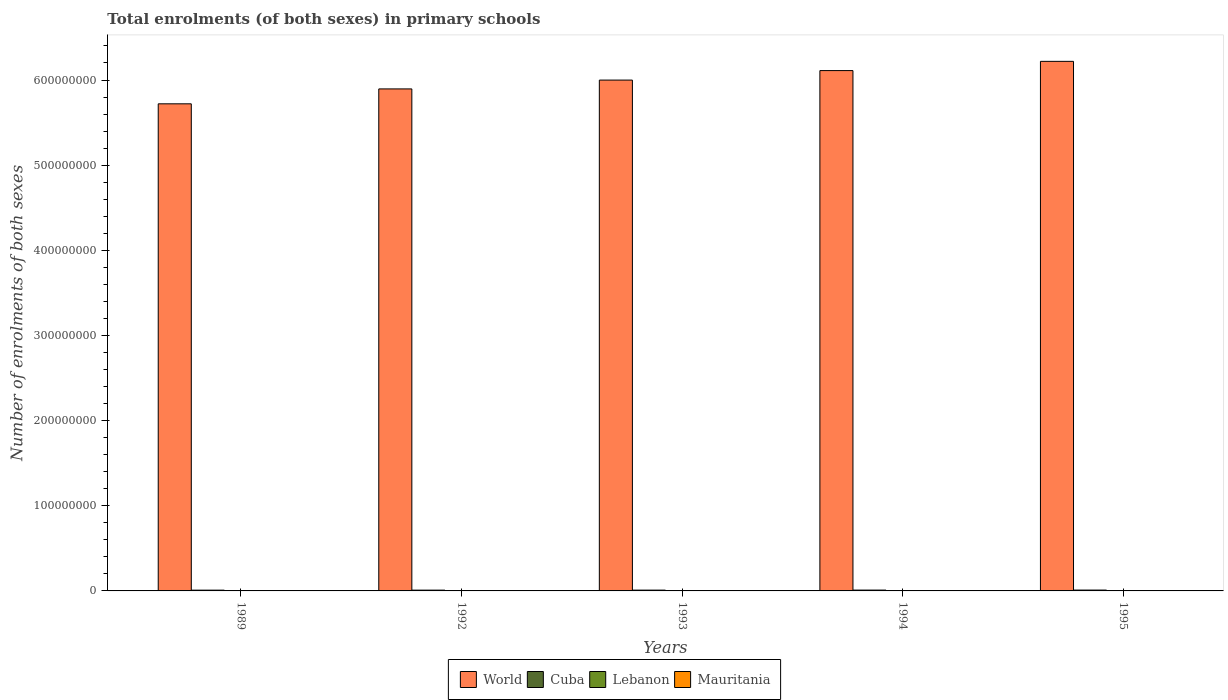Are the number of bars per tick equal to the number of legend labels?
Keep it short and to the point. Yes. How many bars are there on the 1st tick from the right?
Your answer should be very brief. 4. What is the label of the 1st group of bars from the left?
Your answer should be very brief. 1989. What is the number of enrolments in primary schools in World in 1989?
Your answer should be compact. 5.72e+08. Across all years, what is the maximum number of enrolments in primary schools in Cuba?
Make the answer very short. 1.01e+06. Across all years, what is the minimum number of enrolments in primary schools in Cuba?
Make the answer very short. 9.00e+05. In which year was the number of enrolments in primary schools in World minimum?
Make the answer very short. 1989. What is the total number of enrolments in primary schools in Lebanon in the graph?
Provide a succinct answer. 1.76e+06. What is the difference between the number of enrolments in primary schools in Lebanon in 1994 and that in 1995?
Your answer should be very brief. -4316. What is the difference between the number of enrolments in primary schools in Mauritania in 1992 and the number of enrolments in primary schools in Lebanon in 1995?
Your answer should be very brief. -1.77e+05. What is the average number of enrolments in primary schools in World per year?
Provide a short and direct response. 5.99e+08. In the year 1992, what is the difference between the number of enrolments in primary schools in Lebanon and number of enrolments in primary schools in Cuba?
Your response must be concise. -5.72e+05. In how many years, is the number of enrolments in primary schools in Cuba greater than 540000000?
Offer a terse response. 0. What is the ratio of the number of enrolments in primary schools in Mauritania in 1992 to that in 1993?
Ensure brevity in your answer.  0.86. Is the number of enrolments in primary schools in Cuba in 1992 less than that in 1995?
Offer a very short reply. Yes. Is the difference between the number of enrolments in primary schools in Lebanon in 1989 and 1992 greater than the difference between the number of enrolments in primary schools in Cuba in 1989 and 1992?
Offer a terse response. Yes. What is the difference between the highest and the second highest number of enrolments in primary schools in Mauritania?
Give a very brief answer. 2.11e+04. What is the difference between the highest and the lowest number of enrolments in primary schools in World?
Your response must be concise. 4.99e+07. What does the 3rd bar from the left in 1992 represents?
Keep it short and to the point. Lebanon. What does the 2nd bar from the right in 1992 represents?
Provide a short and direct response. Lebanon. How many bars are there?
Keep it short and to the point. 20. Does the graph contain any zero values?
Offer a very short reply. No. How many legend labels are there?
Provide a short and direct response. 4. How are the legend labels stacked?
Provide a succinct answer. Horizontal. What is the title of the graph?
Offer a terse response. Total enrolments (of both sexes) in primary schools. Does "Malawi" appear as one of the legend labels in the graph?
Ensure brevity in your answer.  No. What is the label or title of the X-axis?
Provide a short and direct response. Years. What is the label or title of the Y-axis?
Provide a succinct answer. Number of enrolments of both sexes. What is the Number of enrolments of both sexes in World in 1989?
Provide a short and direct response. 5.72e+08. What is the Number of enrolments of both sexes in Cuba in 1989?
Your answer should be compact. 9.00e+05. What is the Number of enrolments of both sexes in Lebanon in 1989?
Offer a very short reply. 3.47e+05. What is the Number of enrolments of both sexes in Mauritania in 1989?
Ensure brevity in your answer.  1.59e+05. What is the Number of enrolments of both sexes of World in 1992?
Your response must be concise. 5.90e+08. What is the Number of enrolments of both sexes in Cuba in 1992?
Provide a short and direct response. 9.18e+05. What is the Number of enrolments of both sexes of Lebanon in 1992?
Make the answer very short. 3.46e+05. What is the Number of enrolments of both sexes of Mauritania in 1992?
Offer a terse response. 1.89e+05. What is the Number of enrolments of both sexes in World in 1993?
Keep it short and to the point. 6.00e+08. What is the Number of enrolments of both sexes in Cuba in 1993?
Make the answer very short. 9.42e+05. What is the Number of enrolments of both sexes of Lebanon in 1993?
Keep it short and to the point. 3.47e+05. What is the Number of enrolments of both sexes of Mauritania in 1993?
Your response must be concise. 2.19e+05. What is the Number of enrolments of both sexes in World in 1994?
Make the answer very short. 6.11e+08. What is the Number of enrolments of both sexes in Cuba in 1994?
Make the answer very short. 9.83e+05. What is the Number of enrolments of both sexes of Lebanon in 1994?
Offer a very short reply. 3.61e+05. What is the Number of enrolments of both sexes in Mauritania in 1994?
Give a very brief answer. 2.48e+05. What is the Number of enrolments of both sexes in World in 1995?
Make the answer very short. 6.22e+08. What is the Number of enrolments of both sexes of Cuba in 1995?
Offer a terse response. 1.01e+06. What is the Number of enrolments of both sexes in Lebanon in 1995?
Provide a succinct answer. 3.65e+05. What is the Number of enrolments of both sexes of Mauritania in 1995?
Your response must be concise. 2.69e+05. Across all years, what is the maximum Number of enrolments of both sexes of World?
Keep it short and to the point. 6.22e+08. Across all years, what is the maximum Number of enrolments of both sexes in Cuba?
Your response must be concise. 1.01e+06. Across all years, what is the maximum Number of enrolments of both sexes of Lebanon?
Keep it short and to the point. 3.65e+05. Across all years, what is the maximum Number of enrolments of both sexes of Mauritania?
Provide a succinct answer. 2.69e+05. Across all years, what is the minimum Number of enrolments of both sexes of World?
Your answer should be compact. 5.72e+08. Across all years, what is the minimum Number of enrolments of both sexes in Cuba?
Your answer should be compact. 9.00e+05. Across all years, what is the minimum Number of enrolments of both sexes in Lebanon?
Ensure brevity in your answer.  3.46e+05. Across all years, what is the minimum Number of enrolments of both sexes of Mauritania?
Offer a very short reply. 1.59e+05. What is the total Number of enrolments of both sexes in World in the graph?
Your response must be concise. 2.99e+09. What is the total Number of enrolments of both sexes of Cuba in the graph?
Your response must be concise. 4.75e+06. What is the total Number of enrolments of both sexes in Lebanon in the graph?
Keep it short and to the point. 1.76e+06. What is the total Number of enrolments of both sexes in Mauritania in the graph?
Keep it short and to the point. 1.08e+06. What is the difference between the Number of enrolments of both sexes in World in 1989 and that in 1992?
Offer a terse response. -1.75e+07. What is the difference between the Number of enrolments of both sexes in Cuba in 1989 and that in 1992?
Your response must be concise. -1.80e+04. What is the difference between the Number of enrolments of both sexes in Lebanon in 1989 and that in 1992?
Ensure brevity in your answer.  872. What is the difference between the Number of enrolments of both sexes in Mauritania in 1989 and that in 1992?
Offer a very short reply. -2.98e+04. What is the difference between the Number of enrolments of both sexes of World in 1989 and that in 1993?
Provide a short and direct response. -2.79e+07. What is the difference between the Number of enrolments of both sexes in Cuba in 1989 and that in 1993?
Your response must be concise. -4.25e+04. What is the difference between the Number of enrolments of both sexes of Lebanon in 1989 and that in 1993?
Your answer should be compact. -229. What is the difference between the Number of enrolments of both sexes of Mauritania in 1989 and that in 1993?
Keep it short and to the point. -6.05e+04. What is the difference between the Number of enrolments of both sexes in World in 1989 and that in 1994?
Give a very brief answer. -3.90e+07. What is the difference between the Number of enrolments of both sexes in Cuba in 1989 and that in 1994?
Provide a succinct answer. -8.35e+04. What is the difference between the Number of enrolments of both sexes in Lebanon in 1989 and that in 1994?
Offer a very short reply. -1.43e+04. What is the difference between the Number of enrolments of both sexes in Mauritania in 1989 and that in 1994?
Offer a very short reply. -8.92e+04. What is the difference between the Number of enrolments of both sexes of World in 1989 and that in 1995?
Keep it short and to the point. -4.99e+07. What is the difference between the Number of enrolments of both sexes in Cuba in 1989 and that in 1995?
Keep it short and to the point. -1.08e+05. What is the difference between the Number of enrolments of both sexes in Lebanon in 1989 and that in 1995?
Keep it short and to the point. -1.86e+04. What is the difference between the Number of enrolments of both sexes of Mauritania in 1989 and that in 1995?
Keep it short and to the point. -1.10e+05. What is the difference between the Number of enrolments of both sexes of World in 1992 and that in 1993?
Keep it short and to the point. -1.04e+07. What is the difference between the Number of enrolments of both sexes of Cuba in 1992 and that in 1993?
Give a very brief answer. -2.45e+04. What is the difference between the Number of enrolments of both sexes of Lebanon in 1992 and that in 1993?
Give a very brief answer. -1101. What is the difference between the Number of enrolments of both sexes of Mauritania in 1992 and that in 1993?
Make the answer very short. -3.07e+04. What is the difference between the Number of enrolments of both sexes of World in 1992 and that in 1994?
Your answer should be compact. -2.15e+07. What is the difference between the Number of enrolments of both sexes of Cuba in 1992 and that in 1994?
Make the answer very short. -6.56e+04. What is the difference between the Number of enrolments of both sexes of Lebanon in 1992 and that in 1994?
Make the answer very short. -1.52e+04. What is the difference between the Number of enrolments of both sexes in Mauritania in 1992 and that in 1994?
Ensure brevity in your answer.  -5.95e+04. What is the difference between the Number of enrolments of both sexes of World in 1992 and that in 1995?
Make the answer very short. -3.24e+07. What is the difference between the Number of enrolments of both sexes in Cuba in 1992 and that in 1995?
Your answer should be very brief. -8.99e+04. What is the difference between the Number of enrolments of both sexes of Lebanon in 1992 and that in 1995?
Offer a very short reply. -1.95e+04. What is the difference between the Number of enrolments of both sexes in Mauritania in 1992 and that in 1995?
Give a very brief answer. -8.06e+04. What is the difference between the Number of enrolments of both sexes in World in 1993 and that in 1994?
Keep it short and to the point. -1.12e+07. What is the difference between the Number of enrolments of both sexes in Cuba in 1993 and that in 1994?
Offer a terse response. -4.10e+04. What is the difference between the Number of enrolments of both sexes of Lebanon in 1993 and that in 1994?
Provide a succinct answer. -1.41e+04. What is the difference between the Number of enrolments of both sexes in Mauritania in 1993 and that in 1994?
Give a very brief answer. -2.88e+04. What is the difference between the Number of enrolments of both sexes of World in 1993 and that in 1995?
Your answer should be compact. -2.20e+07. What is the difference between the Number of enrolments of both sexes of Cuba in 1993 and that in 1995?
Your response must be concise. -6.53e+04. What is the difference between the Number of enrolments of both sexes of Lebanon in 1993 and that in 1995?
Offer a terse response. -1.84e+04. What is the difference between the Number of enrolments of both sexes of Mauritania in 1993 and that in 1995?
Ensure brevity in your answer.  -4.99e+04. What is the difference between the Number of enrolments of both sexes of World in 1994 and that in 1995?
Your answer should be compact. -1.08e+07. What is the difference between the Number of enrolments of both sexes of Cuba in 1994 and that in 1995?
Offer a terse response. -2.43e+04. What is the difference between the Number of enrolments of both sexes of Lebanon in 1994 and that in 1995?
Keep it short and to the point. -4316. What is the difference between the Number of enrolments of both sexes in Mauritania in 1994 and that in 1995?
Provide a succinct answer. -2.11e+04. What is the difference between the Number of enrolments of both sexes of World in 1989 and the Number of enrolments of both sexes of Cuba in 1992?
Your answer should be very brief. 5.71e+08. What is the difference between the Number of enrolments of both sexes in World in 1989 and the Number of enrolments of both sexes in Lebanon in 1992?
Ensure brevity in your answer.  5.72e+08. What is the difference between the Number of enrolments of both sexes of World in 1989 and the Number of enrolments of both sexes of Mauritania in 1992?
Provide a short and direct response. 5.72e+08. What is the difference between the Number of enrolments of both sexes in Cuba in 1989 and the Number of enrolments of both sexes in Lebanon in 1992?
Ensure brevity in your answer.  5.54e+05. What is the difference between the Number of enrolments of both sexes in Cuba in 1989 and the Number of enrolments of both sexes in Mauritania in 1992?
Give a very brief answer. 7.11e+05. What is the difference between the Number of enrolments of both sexes of Lebanon in 1989 and the Number of enrolments of both sexes of Mauritania in 1992?
Provide a short and direct response. 1.58e+05. What is the difference between the Number of enrolments of both sexes in World in 1989 and the Number of enrolments of both sexes in Cuba in 1993?
Give a very brief answer. 5.71e+08. What is the difference between the Number of enrolments of both sexes in World in 1989 and the Number of enrolments of both sexes in Lebanon in 1993?
Offer a terse response. 5.72e+08. What is the difference between the Number of enrolments of both sexes of World in 1989 and the Number of enrolments of both sexes of Mauritania in 1993?
Offer a terse response. 5.72e+08. What is the difference between the Number of enrolments of both sexes of Cuba in 1989 and the Number of enrolments of both sexes of Lebanon in 1993?
Give a very brief answer. 5.53e+05. What is the difference between the Number of enrolments of both sexes of Cuba in 1989 and the Number of enrolments of both sexes of Mauritania in 1993?
Keep it short and to the point. 6.81e+05. What is the difference between the Number of enrolments of both sexes in Lebanon in 1989 and the Number of enrolments of both sexes in Mauritania in 1993?
Give a very brief answer. 1.27e+05. What is the difference between the Number of enrolments of both sexes of World in 1989 and the Number of enrolments of both sexes of Cuba in 1994?
Offer a very short reply. 5.71e+08. What is the difference between the Number of enrolments of both sexes of World in 1989 and the Number of enrolments of both sexes of Lebanon in 1994?
Make the answer very short. 5.72e+08. What is the difference between the Number of enrolments of both sexes of World in 1989 and the Number of enrolments of both sexes of Mauritania in 1994?
Your response must be concise. 5.72e+08. What is the difference between the Number of enrolments of both sexes of Cuba in 1989 and the Number of enrolments of both sexes of Lebanon in 1994?
Provide a short and direct response. 5.39e+05. What is the difference between the Number of enrolments of both sexes in Cuba in 1989 and the Number of enrolments of both sexes in Mauritania in 1994?
Offer a very short reply. 6.52e+05. What is the difference between the Number of enrolments of both sexes in Lebanon in 1989 and the Number of enrolments of both sexes in Mauritania in 1994?
Your answer should be compact. 9.85e+04. What is the difference between the Number of enrolments of both sexes in World in 1989 and the Number of enrolments of both sexes in Cuba in 1995?
Your answer should be very brief. 5.71e+08. What is the difference between the Number of enrolments of both sexes of World in 1989 and the Number of enrolments of both sexes of Lebanon in 1995?
Make the answer very short. 5.72e+08. What is the difference between the Number of enrolments of both sexes in World in 1989 and the Number of enrolments of both sexes in Mauritania in 1995?
Ensure brevity in your answer.  5.72e+08. What is the difference between the Number of enrolments of both sexes in Cuba in 1989 and the Number of enrolments of both sexes in Lebanon in 1995?
Your answer should be compact. 5.35e+05. What is the difference between the Number of enrolments of both sexes in Cuba in 1989 and the Number of enrolments of both sexes in Mauritania in 1995?
Make the answer very short. 6.31e+05. What is the difference between the Number of enrolments of both sexes of Lebanon in 1989 and the Number of enrolments of both sexes of Mauritania in 1995?
Provide a succinct answer. 7.74e+04. What is the difference between the Number of enrolments of both sexes in World in 1992 and the Number of enrolments of both sexes in Cuba in 1993?
Provide a short and direct response. 5.89e+08. What is the difference between the Number of enrolments of both sexes of World in 1992 and the Number of enrolments of both sexes of Lebanon in 1993?
Give a very brief answer. 5.89e+08. What is the difference between the Number of enrolments of both sexes of World in 1992 and the Number of enrolments of both sexes of Mauritania in 1993?
Your answer should be compact. 5.89e+08. What is the difference between the Number of enrolments of both sexes in Cuba in 1992 and the Number of enrolments of both sexes in Lebanon in 1993?
Offer a very short reply. 5.71e+05. What is the difference between the Number of enrolments of both sexes of Cuba in 1992 and the Number of enrolments of both sexes of Mauritania in 1993?
Offer a terse response. 6.99e+05. What is the difference between the Number of enrolments of both sexes of Lebanon in 1992 and the Number of enrolments of both sexes of Mauritania in 1993?
Offer a very short reply. 1.26e+05. What is the difference between the Number of enrolments of both sexes in World in 1992 and the Number of enrolments of both sexes in Cuba in 1994?
Your answer should be very brief. 5.89e+08. What is the difference between the Number of enrolments of both sexes of World in 1992 and the Number of enrolments of both sexes of Lebanon in 1994?
Offer a terse response. 5.89e+08. What is the difference between the Number of enrolments of both sexes in World in 1992 and the Number of enrolments of both sexes in Mauritania in 1994?
Keep it short and to the point. 5.89e+08. What is the difference between the Number of enrolments of both sexes in Cuba in 1992 and the Number of enrolments of both sexes in Lebanon in 1994?
Your answer should be compact. 5.57e+05. What is the difference between the Number of enrolments of both sexes in Cuba in 1992 and the Number of enrolments of both sexes in Mauritania in 1994?
Keep it short and to the point. 6.70e+05. What is the difference between the Number of enrolments of both sexes of Lebanon in 1992 and the Number of enrolments of both sexes of Mauritania in 1994?
Your answer should be very brief. 9.76e+04. What is the difference between the Number of enrolments of both sexes in World in 1992 and the Number of enrolments of both sexes in Cuba in 1995?
Offer a terse response. 5.89e+08. What is the difference between the Number of enrolments of both sexes of World in 1992 and the Number of enrolments of both sexes of Lebanon in 1995?
Provide a succinct answer. 5.89e+08. What is the difference between the Number of enrolments of both sexes in World in 1992 and the Number of enrolments of both sexes in Mauritania in 1995?
Provide a short and direct response. 5.89e+08. What is the difference between the Number of enrolments of both sexes of Cuba in 1992 and the Number of enrolments of both sexes of Lebanon in 1995?
Keep it short and to the point. 5.53e+05. What is the difference between the Number of enrolments of both sexes in Cuba in 1992 and the Number of enrolments of both sexes in Mauritania in 1995?
Your response must be concise. 6.49e+05. What is the difference between the Number of enrolments of both sexes of Lebanon in 1992 and the Number of enrolments of both sexes of Mauritania in 1995?
Provide a succinct answer. 7.65e+04. What is the difference between the Number of enrolments of both sexes of World in 1993 and the Number of enrolments of both sexes of Cuba in 1994?
Offer a terse response. 5.99e+08. What is the difference between the Number of enrolments of both sexes of World in 1993 and the Number of enrolments of both sexes of Lebanon in 1994?
Make the answer very short. 6.00e+08. What is the difference between the Number of enrolments of both sexes of World in 1993 and the Number of enrolments of both sexes of Mauritania in 1994?
Make the answer very short. 6.00e+08. What is the difference between the Number of enrolments of both sexes of Cuba in 1993 and the Number of enrolments of both sexes of Lebanon in 1994?
Your response must be concise. 5.82e+05. What is the difference between the Number of enrolments of both sexes in Cuba in 1993 and the Number of enrolments of both sexes in Mauritania in 1994?
Offer a terse response. 6.94e+05. What is the difference between the Number of enrolments of both sexes in Lebanon in 1993 and the Number of enrolments of both sexes in Mauritania in 1994?
Give a very brief answer. 9.87e+04. What is the difference between the Number of enrolments of both sexes in World in 1993 and the Number of enrolments of both sexes in Cuba in 1995?
Your answer should be compact. 5.99e+08. What is the difference between the Number of enrolments of both sexes in World in 1993 and the Number of enrolments of both sexes in Lebanon in 1995?
Your response must be concise. 6.00e+08. What is the difference between the Number of enrolments of both sexes of World in 1993 and the Number of enrolments of both sexes of Mauritania in 1995?
Offer a terse response. 6.00e+08. What is the difference between the Number of enrolments of both sexes in Cuba in 1993 and the Number of enrolments of both sexes in Lebanon in 1995?
Provide a short and direct response. 5.77e+05. What is the difference between the Number of enrolments of both sexes of Cuba in 1993 and the Number of enrolments of both sexes of Mauritania in 1995?
Offer a very short reply. 6.73e+05. What is the difference between the Number of enrolments of both sexes in Lebanon in 1993 and the Number of enrolments of both sexes in Mauritania in 1995?
Offer a very short reply. 7.76e+04. What is the difference between the Number of enrolments of both sexes of World in 1994 and the Number of enrolments of both sexes of Cuba in 1995?
Your response must be concise. 6.10e+08. What is the difference between the Number of enrolments of both sexes in World in 1994 and the Number of enrolments of both sexes in Lebanon in 1995?
Ensure brevity in your answer.  6.11e+08. What is the difference between the Number of enrolments of both sexes of World in 1994 and the Number of enrolments of both sexes of Mauritania in 1995?
Make the answer very short. 6.11e+08. What is the difference between the Number of enrolments of both sexes in Cuba in 1994 and the Number of enrolments of both sexes in Lebanon in 1995?
Your response must be concise. 6.18e+05. What is the difference between the Number of enrolments of both sexes of Cuba in 1994 and the Number of enrolments of both sexes of Mauritania in 1995?
Keep it short and to the point. 7.14e+05. What is the difference between the Number of enrolments of both sexes of Lebanon in 1994 and the Number of enrolments of both sexes of Mauritania in 1995?
Your answer should be very brief. 9.17e+04. What is the average Number of enrolments of both sexes in World per year?
Offer a terse response. 5.99e+08. What is the average Number of enrolments of both sexes of Cuba per year?
Your answer should be very brief. 9.50e+05. What is the average Number of enrolments of both sexes in Lebanon per year?
Give a very brief answer. 3.53e+05. What is the average Number of enrolments of both sexes in Mauritania per year?
Offer a terse response. 2.17e+05. In the year 1989, what is the difference between the Number of enrolments of both sexes in World and Number of enrolments of both sexes in Cuba?
Make the answer very short. 5.71e+08. In the year 1989, what is the difference between the Number of enrolments of both sexes of World and Number of enrolments of both sexes of Lebanon?
Your response must be concise. 5.72e+08. In the year 1989, what is the difference between the Number of enrolments of both sexes in World and Number of enrolments of both sexes in Mauritania?
Offer a terse response. 5.72e+08. In the year 1989, what is the difference between the Number of enrolments of both sexes in Cuba and Number of enrolments of both sexes in Lebanon?
Provide a succinct answer. 5.53e+05. In the year 1989, what is the difference between the Number of enrolments of both sexes of Cuba and Number of enrolments of both sexes of Mauritania?
Provide a short and direct response. 7.41e+05. In the year 1989, what is the difference between the Number of enrolments of both sexes of Lebanon and Number of enrolments of both sexes of Mauritania?
Keep it short and to the point. 1.88e+05. In the year 1992, what is the difference between the Number of enrolments of both sexes of World and Number of enrolments of both sexes of Cuba?
Provide a short and direct response. 5.89e+08. In the year 1992, what is the difference between the Number of enrolments of both sexes of World and Number of enrolments of both sexes of Lebanon?
Give a very brief answer. 5.89e+08. In the year 1992, what is the difference between the Number of enrolments of both sexes in World and Number of enrolments of both sexes in Mauritania?
Give a very brief answer. 5.89e+08. In the year 1992, what is the difference between the Number of enrolments of both sexes of Cuba and Number of enrolments of both sexes of Lebanon?
Ensure brevity in your answer.  5.72e+05. In the year 1992, what is the difference between the Number of enrolments of both sexes in Cuba and Number of enrolments of both sexes in Mauritania?
Your answer should be very brief. 7.29e+05. In the year 1992, what is the difference between the Number of enrolments of both sexes of Lebanon and Number of enrolments of both sexes of Mauritania?
Your response must be concise. 1.57e+05. In the year 1993, what is the difference between the Number of enrolments of both sexes of World and Number of enrolments of both sexes of Cuba?
Keep it short and to the point. 5.99e+08. In the year 1993, what is the difference between the Number of enrolments of both sexes in World and Number of enrolments of both sexes in Lebanon?
Your answer should be very brief. 6.00e+08. In the year 1993, what is the difference between the Number of enrolments of both sexes in World and Number of enrolments of both sexes in Mauritania?
Your response must be concise. 6.00e+08. In the year 1993, what is the difference between the Number of enrolments of both sexes of Cuba and Number of enrolments of both sexes of Lebanon?
Provide a short and direct response. 5.96e+05. In the year 1993, what is the difference between the Number of enrolments of both sexes in Cuba and Number of enrolments of both sexes in Mauritania?
Provide a succinct answer. 7.23e+05. In the year 1993, what is the difference between the Number of enrolments of both sexes in Lebanon and Number of enrolments of both sexes in Mauritania?
Ensure brevity in your answer.  1.28e+05. In the year 1994, what is the difference between the Number of enrolments of both sexes in World and Number of enrolments of both sexes in Cuba?
Provide a succinct answer. 6.10e+08. In the year 1994, what is the difference between the Number of enrolments of both sexes of World and Number of enrolments of both sexes of Lebanon?
Offer a very short reply. 6.11e+08. In the year 1994, what is the difference between the Number of enrolments of both sexes of World and Number of enrolments of both sexes of Mauritania?
Offer a very short reply. 6.11e+08. In the year 1994, what is the difference between the Number of enrolments of both sexes in Cuba and Number of enrolments of both sexes in Lebanon?
Give a very brief answer. 6.23e+05. In the year 1994, what is the difference between the Number of enrolments of both sexes in Cuba and Number of enrolments of both sexes in Mauritania?
Ensure brevity in your answer.  7.35e+05. In the year 1994, what is the difference between the Number of enrolments of both sexes in Lebanon and Number of enrolments of both sexes in Mauritania?
Provide a short and direct response. 1.13e+05. In the year 1995, what is the difference between the Number of enrolments of both sexes of World and Number of enrolments of both sexes of Cuba?
Provide a succinct answer. 6.21e+08. In the year 1995, what is the difference between the Number of enrolments of both sexes of World and Number of enrolments of both sexes of Lebanon?
Your answer should be very brief. 6.22e+08. In the year 1995, what is the difference between the Number of enrolments of both sexes in World and Number of enrolments of both sexes in Mauritania?
Provide a short and direct response. 6.22e+08. In the year 1995, what is the difference between the Number of enrolments of both sexes of Cuba and Number of enrolments of both sexes of Lebanon?
Give a very brief answer. 6.43e+05. In the year 1995, what is the difference between the Number of enrolments of both sexes of Cuba and Number of enrolments of both sexes of Mauritania?
Provide a short and direct response. 7.39e+05. In the year 1995, what is the difference between the Number of enrolments of both sexes of Lebanon and Number of enrolments of both sexes of Mauritania?
Keep it short and to the point. 9.60e+04. What is the ratio of the Number of enrolments of both sexes in World in 1989 to that in 1992?
Your answer should be compact. 0.97. What is the ratio of the Number of enrolments of both sexes of Cuba in 1989 to that in 1992?
Make the answer very short. 0.98. What is the ratio of the Number of enrolments of both sexes of Lebanon in 1989 to that in 1992?
Ensure brevity in your answer.  1. What is the ratio of the Number of enrolments of both sexes in Mauritania in 1989 to that in 1992?
Offer a very short reply. 0.84. What is the ratio of the Number of enrolments of both sexes in World in 1989 to that in 1993?
Ensure brevity in your answer.  0.95. What is the ratio of the Number of enrolments of both sexes in Cuba in 1989 to that in 1993?
Provide a succinct answer. 0.95. What is the ratio of the Number of enrolments of both sexes of Mauritania in 1989 to that in 1993?
Provide a short and direct response. 0.72. What is the ratio of the Number of enrolments of both sexes of World in 1989 to that in 1994?
Your answer should be compact. 0.94. What is the ratio of the Number of enrolments of both sexes in Cuba in 1989 to that in 1994?
Give a very brief answer. 0.92. What is the ratio of the Number of enrolments of both sexes of Lebanon in 1989 to that in 1994?
Your response must be concise. 0.96. What is the ratio of the Number of enrolments of both sexes of Mauritania in 1989 to that in 1994?
Provide a succinct answer. 0.64. What is the ratio of the Number of enrolments of both sexes in World in 1989 to that in 1995?
Make the answer very short. 0.92. What is the ratio of the Number of enrolments of both sexes of Cuba in 1989 to that in 1995?
Ensure brevity in your answer.  0.89. What is the ratio of the Number of enrolments of both sexes in Lebanon in 1989 to that in 1995?
Give a very brief answer. 0.95. What is the ratio of the Number of enrolments of both sexes in Mauritania in 1989 to that in 1995?
Your response must be concise. 0.59. What is the ratio of the Number of enrolments of both sexes of World in 1992 to that in 1993?
Give a very brief answer. 0.98. What is the ratio of the Number of enrolments of both sexes in Cuba in 1992 to that in 1993?
Provide a short and direct response. 0.97. What is the ratio of the Number of enrolments of both sexes in Mauritania in 1992 to that in 1993?
Offer a very short reply. 0.86. What is the ratio of the Number of enrolments of both sexes of World in 1992 to that in 1994?
Provide a succinct answer. 0.96. What is the ratio of the Number of enrolments of both sexes of Cuba in 1992 to that in 1994?
Offer a very short reply. 0.93. What is the ratio of the Number of enrolments of both sexes in Lebanon in 1992 to that in 1994?
Ensure brevity in your answer.  0.96. What is the ratio of the Number of enrolments of both sexes of Mauritania in 1992 to that in 1994?
Offer a very short reply. 0.76. What is the ratio of the Number of enrolments of both sexes of World in 1992 to that in 1995?
Give a very brief answer. 0.95. What is the ratio of the Number of enrolments of both sexes of Cuba in 1992 to that in 1995?
Your answer should be very brief. 0.91. What is the ratio of the Number of enrolments of both sexes in Lebanon in 1992 to that in 1995?
Give a very brief answer. 0.95. What is the ratio of the Number of enrolments of both sexes of Mauritania in 1992 to that in 1995?
Your answer should be very brief. 0.7. What is the ratio of the Number of enrolments of both sexes in World in 1993 to that in 1994?
Offer a very short reply. 0.98. What is the ratio of the Number of enrolments of both sexes in Cuba in 1993 to that in 1994?
Ensure brevity in your answer.  0.96. What is the ratio of the Number of enrolments of both sexes in Lebanon in 1993 to that in 1994?
Ensure brevity in your answer.  0.96. What is the ratio of the Number of enrolments of both sexes of Mauritania in 1993 to that in 1994?
Make the answer very short. 0.88. What is the ratio of the Number of enrolments of both sexes in World in 1993 to that in 1995?
Your answer should be compact. 0.96. What is the ratio of the Number of enrolments of both sexes of Cuba in 1993 to that in 1995?
Give a very brief answer. 0.94. What is the ratio of the Number of enrolments of both sexes of Lebanon in 1993 to that in 1995?
Your answer should be very brief. 0.95. What is the ratio of the Number of enrolments of both sexes in Mauritania in 1993 to that in 1995?
Provide a succinct answer. 0.81. What is the ratio of the Number of enrolments of both sexes in World in 1994 to that in 1995?
Your answer should be compact. 0.98. What is the ratio of the Number of enrolments of both sexes in Cuba in 1994 to that in 1995?
Offer a terse response. 0.98. What is the ratio of the Number of enrolments of both sexes in Mauritania in 1994 to that in 1995?
Provide a succinct answer. 0.92. What is the difference between the highest and the second highest Number of enrolments of both sexes in World?
Make the answer very short. 1.08e+07. What is the difference between the highest and the second highest Number of enrolments of both sexes of Cuba?
Ensure brevity in your answer.  2.43e+04. What is the difference between the highest and the second highest Number of enrolments of both sexes of Lebanon?
Ensure brevity in your answer.  4316. What is the difference between the highest and the second highest Number of enrolments of both sexes in Mauritania?
Provide a short and direct response. 2.11e+04. What is the difference between the highest and the lowest Number of enrolments of both sexes in World?
Your answer should be very brief. 4.99e+07. What is the difference between the highest and the lowest Number of enrolments of both sexes in Cuba?
Offer a terse response. 1.08e+05. What is the difference between the highest and the lowest Number of enrolments of both sexes in Lebanon?
Ensure brevity in your answer.  1.95e+04. What is the difference between the highest and the lowest Number of enrolments of both sexes in Mauritania?
Your response must be concise. 1.10e+05. 